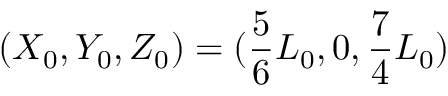Convert formula to latex. <formula><loc_0><loc_0><loc_500><loc_500>( X _ { 0 } , Y _ { 0 } , Z _ { 0 } ) = ( \frac { 5 } { 6 } L _ { 0 } , 0 , \frac { 7 } { 4 } L _ { 0 } )</formula> 